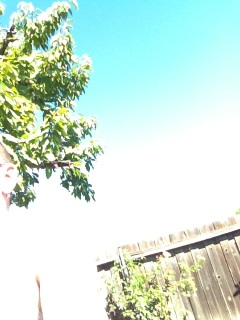What is this? from Vizwiz tree 